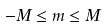Convert formula to latex. <formula><loc_0><loc_0><loc_500><loc_500>- M \leq m \leq M</formula> 